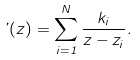<formula> <loc_0><loc_0><loc_500><loc_500>\varphi ( z ) = \sum _ { i = 1 } ^ { N } \frac { k _ { i } } { z - z _ { i } } .</formula> 